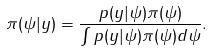Convert formula to latex. <formula><loc_0><loc_0><loc_500><loc_500>\pi ( \psi | y ) = \frac { p ( y | \psi ) \pi ( \psi ) } { \int p ( y | \psi ) \pi ( \psi ) d \psi } .</formula> 